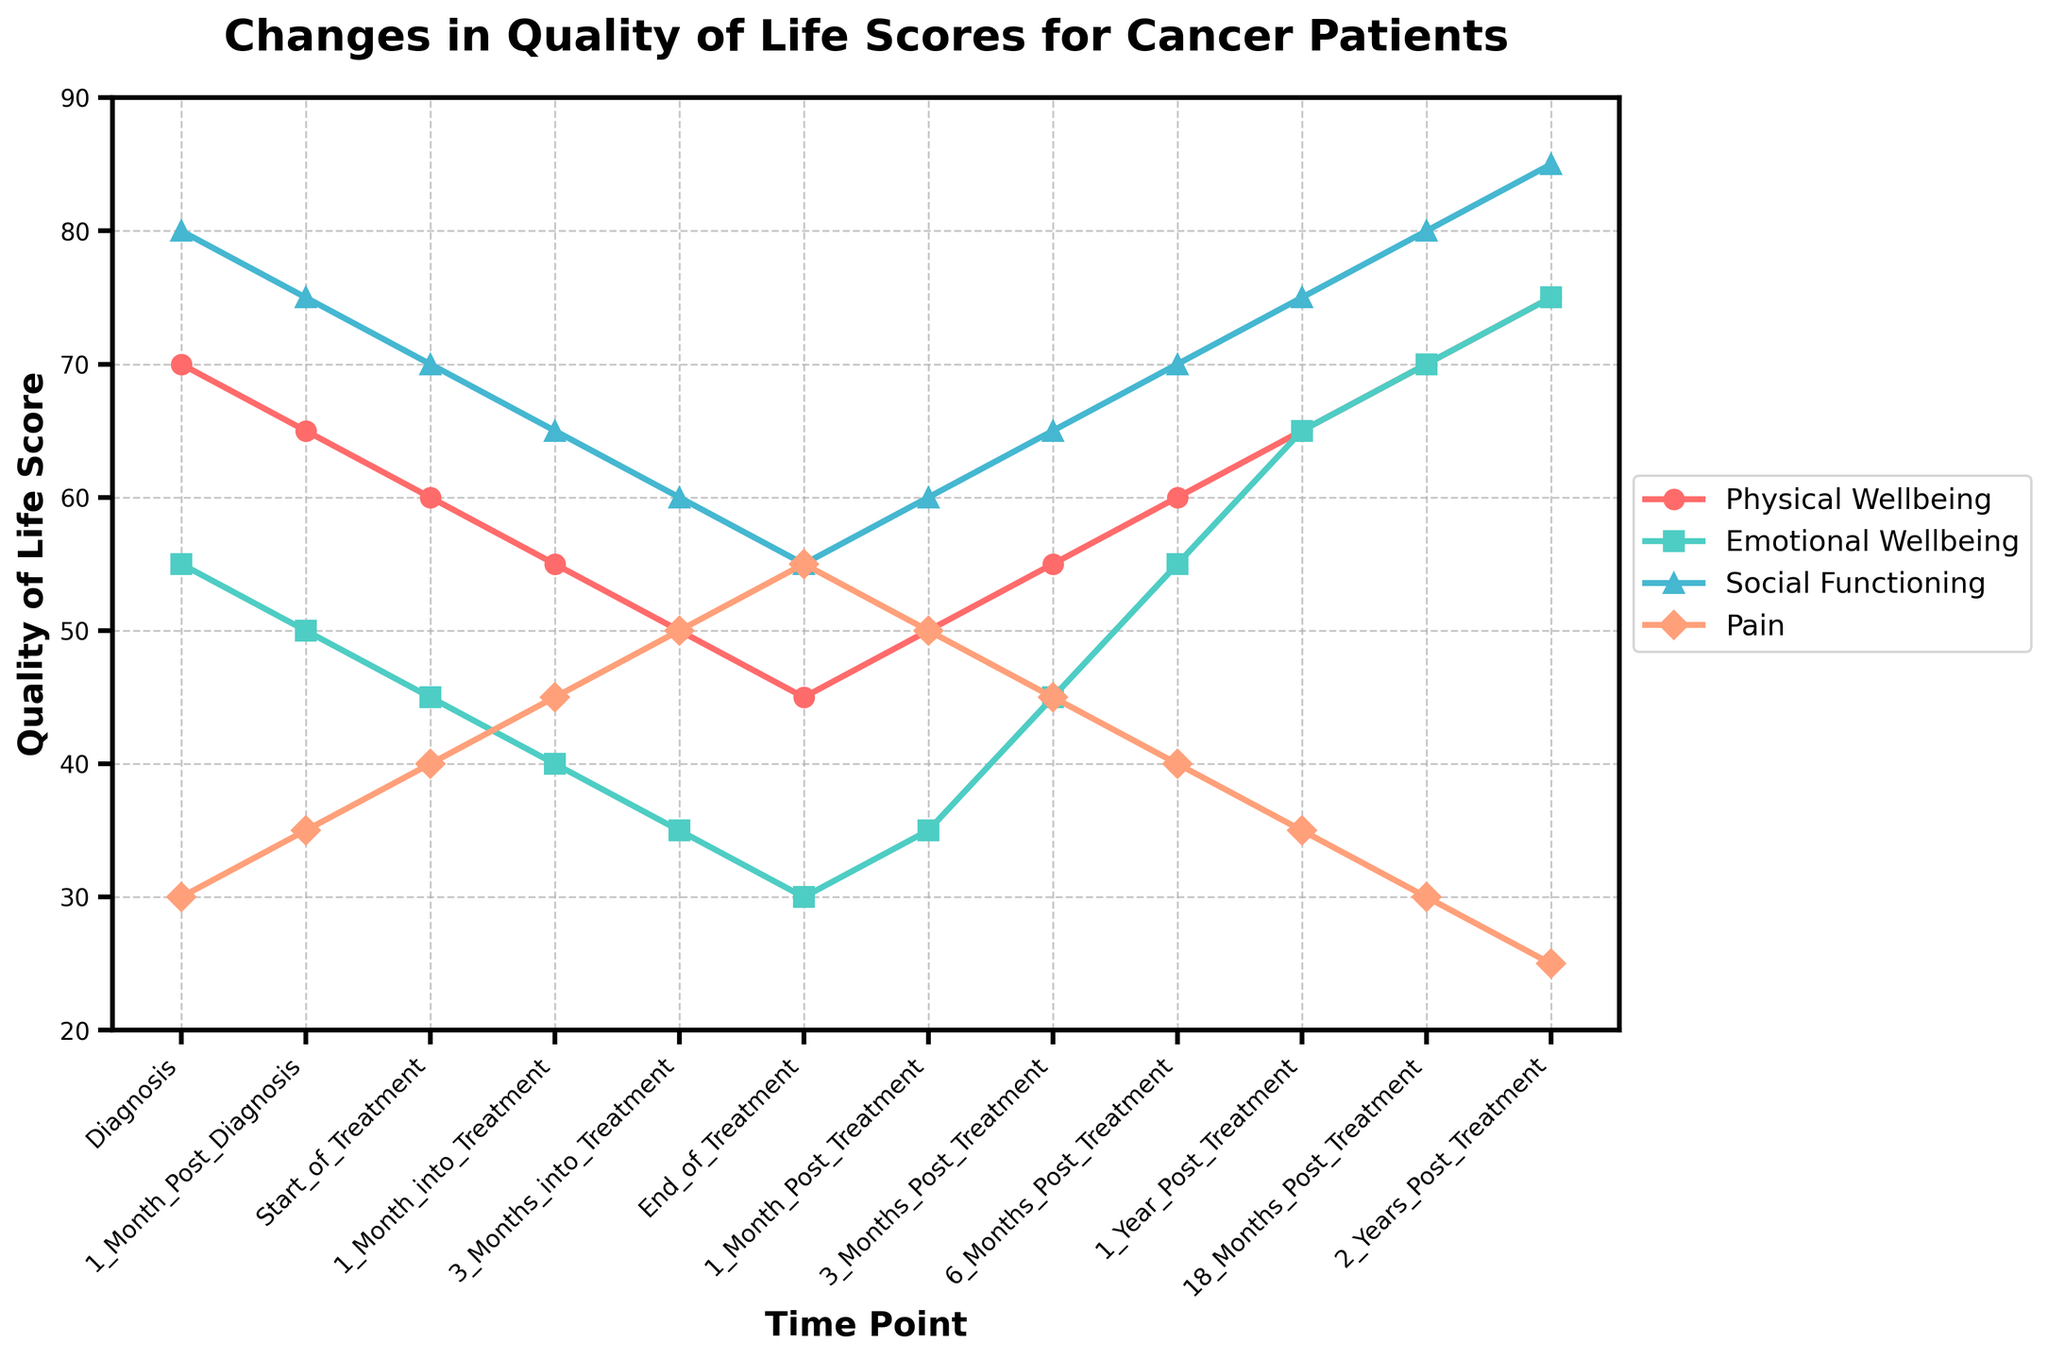Which time point shows the lowest Physical Wellbeing score? The line for Physical Wellbeing reaches its lowest point, around 45, at the "End_of_Treatment" time point.
Answer: End_of_Treatment How does Emotional Wellbeing change from the Start_of_Treatment to the End_of_Treatment? The Emotional Wellbeing score decreases from 45 at the Start_of_Treatment to 30 at the End_of_Treatment.
Answer: It decreases by 15 Which Quality of Life measure has the steepest decline between Diagnosis and 1_Month_Post_Diagnosis? Comparing the differences for each measure, Physical Wellbeing drops by 5 (70 to 65), Emotional Wellbeing drops by 5 (55 to 50), Social Functioning drops by 5 (80 to 75), and Pain increases by 5 (30 to 35).
Answer: All measures except Pain decrease equally by 5 Is Pain higher or lower at the End_of_Treatment compared to Diagnosis? The Pain score at Diagnosis is 30 and at the End_of_Treatment is 55.
Answer: Higher What is the difference in Physical Wellbeing between Diagnosis and 2_Years_Post_Treatment? Physical Wellbeing at Diagnosis is 70 and at 2_Years_Post_Treatment is 75. The difference is 75 - 70.
Answer: 5 Which Quality of Life measure returns to its initial value first after the end of treatment? Comparing the values at Diagnosis and different Post_Treatment time points, Emotional Wellbeing first returns to its initial value of 55 after 6 months.
Answer: Emotional Wellbeing During which period does Pain reach its highest level? The Pain line reaches its highest point of 55 at the End_of_Treatment.
Answer: End_of_Treatment At which time point do Social Functioning and Physical Wellbeing reach the same score for the first time? Social Functioning and Physical Wellbeing first both reach 60 at 6_Months_Post_Treatment.
Answer: 6_Months_Post_Treatment Which measure has the greatest improvement between End_of_Treatment and 3_Months_Post_Treatment? Comparing the changes: Physical Wellbeing increases by 5 (45 to 50), Emotional Wellbeing increases by 5 (30 to 35), Social Functioning increases by 5 (55 to 60), and Pain decreases by 5 (55 to 50).
Answer: All measures except Pain improve equally by 5 How many time points show an Emotional Wellbeing score higher than 50? The Emotional Wellbeing scores are higher than 50 at 6_Months_Post_Treatment, 1_Year_Post_Treatment, 18_Months_Post_Treatment, and 2_Years_Post_Treatment.
Answer: 4 